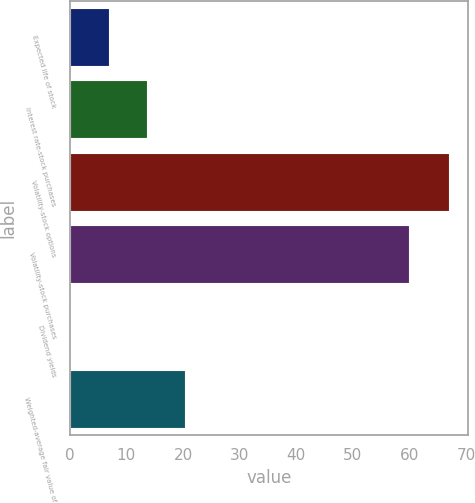<chart> <loc_0><loc_0><loc_500><loc_500><bar_chart><fcel>Expected life of stock<fcel>Interest rate-stock purchases<fcel>Volatility-stock options<fcel>Volatility-stock purchases<fcel>Dividend yields<fcel>Weighted-average fair value of<nl><fcel>6.96<fcel>13.63<fcel>67<fcel>60<fcel>0.29<fcel>20.3<nl></chart> 